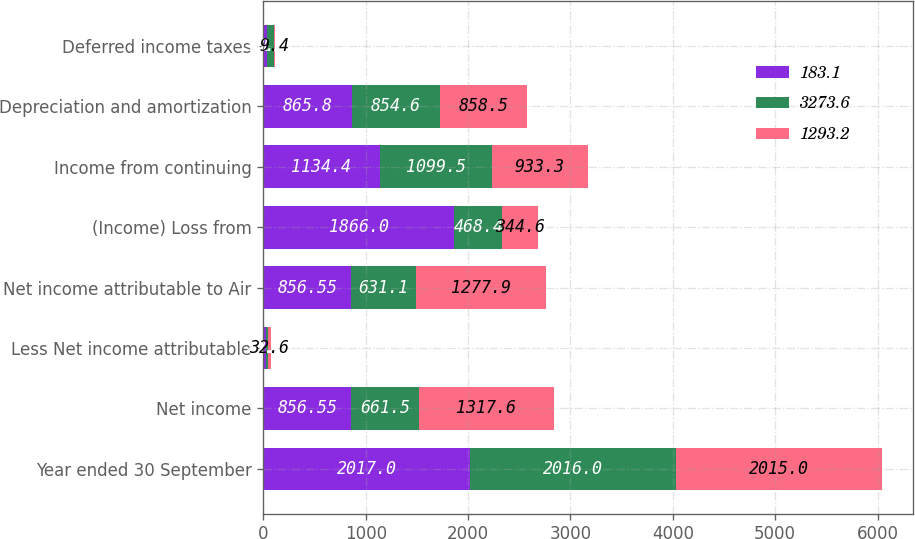Convert chart. <chart><loc_0><loc_0><loc_500><loc_500><stacked_bar_chart><ecel><fcel>Year ended 30 September<fcel>Net income<fcel>Less Net income attributable<fcel>Net income attributable to Air<fcel>(Income) Loss from<fcel>Income from continuing<fcel>Depreciation and amortization<fcel>Deferred income taxes<nl><fcel>183.1<fcel>2017<fcel>856.55<fcel>20.8<fcel>856.55<fcel>1866<fcel>1134.4<fcel>865.8<fcel>38<nl><fcel>3273.6<fcel>2016<fcel>661.5<fcel>22.5<fcel>631.1<fcel>468.4<fcel>1099.5<fcel>854.6<fcel>61.8<nl><fcel>1293.2<fcel>2015<fcel>1317.6<fcel>32.6<fcel>1277.9<fcel>344.6<fcel>933.3<fcel>858.5<fcel>9.4<nl></chart> 